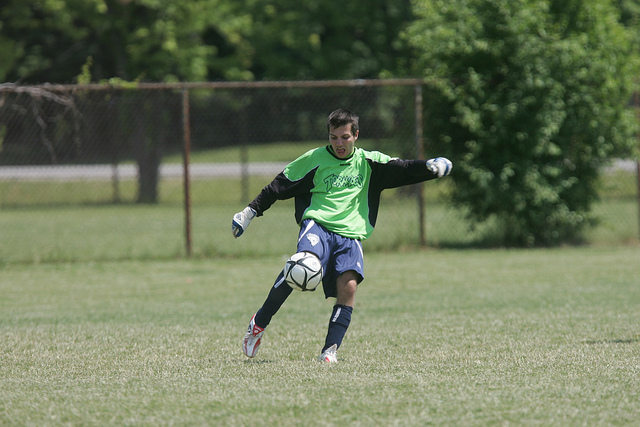<image>Is the guy good? I don't know if the guy is good or not. Is the guy good? I don't know if the guy is good. 